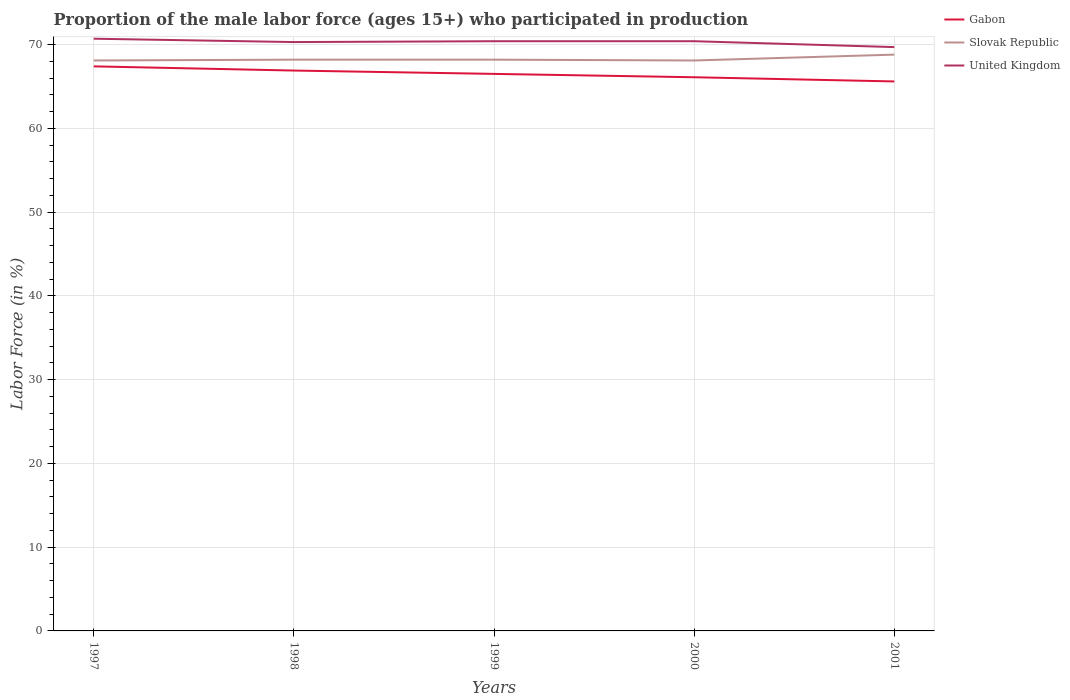Does the line corresponding to Gabon intersect with the line corresponding to Slovak Republic?
Your answer should be compact. No. Across all years, what is the maximum proportion of the male labor force who participated in production in United Kingdom?
Offer a very short reply. 69.7. What is the total proportion of the male labor force who participated in production in Gabon in the graph?
Offer a terse response. 1.3. What is the difference between the highest and the second highest proportion of the male labor force who participated in production in United Kingdom?
Provide a succinct answer. 1. Is the proportion of the male labor force who participated in production in Gabon strictly greater than the proportion of the male labor force who participated in production in Slovak Republic over the years?
Offer a very short reply. Yes. How many lines are there?
Your answer should be very brief. 3. Are the values on the major ticks of Y-axis written in scientific E-notation?
Give a very brief answer. No. Does the graph contain grids?
Make the answer very short. Yes. Where does the legend appear in the graph?
Give a very brief answer. Top right. How many legend labels are there?
Make the answer very short. 3. What is the title of the graph?
Provide a short and direct response. Proportion of the male labor force (ages 15+) who participated in production. What is the label or title of the X-axis?
Keep it short and to the point. Years. What is the label or title of the Y-axis?
Your answer should be very brief. Labor Force (in %). What is the Labor Force (in %) in Gabon in 1997?
Make the answer very short. 67.4. What is the Labor Force (in %) in Slovak Republic in 1997?
Provide a succinct answer. 68.1. What is the Labor Force (in %) of United Kingdom in 1997?
Make the answer very short. 70.7. What is the Labor Force (in %) in Gabon in 1998?
Offer a terse response. 66.9. What is the Labor Force (in %) in Slovak Republic in 1998?
Ensure brevity in your answer.  68.2. What is the Labor Force (in %) of United Kingdom in 1998?
Your answer should be very brief. 70.3. What is the Labor Force (in %) of Gabon in 1999?
Make the answer very short. 66.5. What is the Labor Force (in %) of Slovak Republic in 1999?
Provide a succinct answer. 68.2. What is the Labor Force (in %) of United Kingdom in 1999?
Your answer should be very brief. 70.4. What is the Labor Force (in %) in Gabon in 2000?
Offer a terse response. 66.1. What is the Labor Force (in %) of Slovak Republic in 2000?
Offer a very short reply. 68.1. What is the Labor Force (in %) of United Kingdom in 2000?
Your response must be concise. 70.4. What is the Labor Force (in %) in Gabon in 2001?
Your answer should be compact. 65.6. What is the Labor Force (in %) in Slovak Republic in 2001?
Offer a very short reply. 68.8. What is the Labor Force (in %) in United Kingdom in 2001?
Keep it short and to the point. 69.7. Across all years, what is the maximum Labor Force (in %) in Gabon?
Provide a succinct answer. 67.4. Across all years, what is the maximum Labor Force (in %) of Slovak Republic?
Make the answer very short. 68.8. Across all years, what is the maximum Labor Force (in %) in United Kingdom?
Your response must be concise. 70.7. Across all years, what is the minimum Labor Force (in %) in Gabon?
Your answer should be very brief. 65.6. Across all years, what is the minimum Labor Force (in %) of Slovak Republic?
Offer a very short reply. 68.1. Across all years, what is the minimum Labor Force (in %) of United Kingdom?
Provide a succinct answer. 69.7. What is the total Labor Force (in %) of Gabon in the graph?
Make the answer very short. 332.5. What is the total Labor Force (in %) of Slovak Republic in the graph?
Ensure brevity in your answer.  341.4. What is the total Labor Force (in %) in United Kingdom in the graph?
Make the answer very short. 351.5. What is the difference between the Labor Force (in %) in Gabon in 1997 and that in 1998?
Offer a terse response. 0.5. What is the difference between the Labor Force (in %) of United Kingdom in 1997 and that in 1998?
Make the answer very short. 0.4. What is the difference between the Labor Force (in %) of Gabon in 1997 and that in 1999?
Keep it short and to the point. 0.9. What is the difference between the Labor Force (in %) of United Kingdom in 1997 and that in 1999?
Your answer should be compact. 0.3. What is the difference between the Labor Force (in %) of Slovak Republic in 1997 and that in 2000?
Your answer should be compact. 0. What is the difference between the Labor Force (in %) of United Kingdom in 1997 and that in 2000?
Provide a succinct answer. 0.3. What is the difference between the Labor Force (in %) in Slovak Republic in 1997 and that in 2001?
Offer a terse response. -0.7. What is the difference between the Labor Force (in %) of Gabon in 1998 and that in 1999?
Offer a terse response. 0.4. What is the difference between the Labor Force (in %) of United Kingdom in 1998 and that in 1999?
Provide a short and direct response. -0.1. What is the difference between the Labor Force (in %) of Gabon in 1998 and that in 2000?
Your answer should be very brief. 0.8. What is the difference between the Labor Force (in %) of Slovak Republic in 1998 and that in 2000?
Give a very brief answer. 0.1. What is the difference between the Labor Force (in %) of United Kingdom in 1998 and that in 2000?
Keep it short and to the point. -0.1. What is the difference between the Labor Force (in %) of Slovak Republic in 1998 and that in 2001?
Provide a short and direct response. -0.6. What is the difference between the Labor Force (in %) in United Kingdom in 1999 and that in 2000?
Ensure brevity in your answer.  0. What is the difference between the Labor Force (in %) of Gabon in 1999 and that in 2001?
Provide a succinct answer. 0.9. What is the difference between the Labor Force (in %) in Gabon in 2000 and that in 2001?
Your answer should be compact. 0.5. What is the difference between the Labor Force (in %) of Slovak Republic in 2000 and that in 2001?
Make the answer very short. -0.7. What is the difference between the Labor Force (in %) of United Kingdom in 2000 and that in 2001?
Provide a short and direct response. 0.7. What is the difference between the Labor Force (in %) in Gabon in 1997 and the Labor Force (in %) in United Kingdom in 1998?
Your response must be concise. -2.9. What is the difference between the Labor Force (in %) of Gabon in 1997 and the Labor Force (in %) of Slovak Republic in 1999?
Give a very brief answer. -0.8. What is the difference between the Labor Force (in %) of Gabon in 1997 and the Labor Force (in %) of United Kingdom in 1999?
Offer a terse response. -3. What is the difference between the Labor Force (in %) of Slovak Republic in 1997 and the Labor Force (in %) of United Kingdom in 1999?
Give a very brief answer. -2.3. What is the difference between the Labor Force (in %) in Slovak Republic in 1997 and the Labor Force (in %) in United Kingdom in 2000?
Ensure brevity in your answer.  -2.3. What is the difference between the Labor Force (in %) in Gabon in 1997 and the Labor Force (in %) in Slovak Republic in 2001?
Keep it short and to the point. -1.4. What is the difference between the Labor Force (in %) of Slovak Republic in 1997 and the Labor Force (in %) of United Kingdom in 2001?
Your answer should be very brief. -1.6. What is the difference between the Labor Force (in %) of Gabon in 1998 and the Labor Force (in %) of United Kingdom in 1999?
Your response must be concise. -3.5. What is the difference between the Labor Force (in %) of Slovak Republic in 1998 and the Labor Force (in %) of United Kingdom in 1999?
Ensure brevity in your answer.  -2.2. What is the difference between the Labor Force (in %) in Gabon in 1998 and the Labor Force (in %) in Slovak Republic in 2000?
Keep it short and to the point. -1.2. What is the difference between the Labor Force (in %) in Gabon in 1998 and the Labor Force (in %) in United Kingdom in 2000?
Ensure brevity in your answer.  -3.5. What is the difference between the Labor Force (in %) of Slovak Republic in 1998 and the Labor Force (in %) of United Kingdom in 2000?
Offer a very short reply. -2.2. What is the difference between the Labor Force (in %) of Gabon in 1998 and the Labor Force (in %) of Slovak Republic in 2001?
Offer a very short reply. -1.9. What is the difference between the Labor Force (in %) of Gabon in 1999 and the Labor Force (in %) of Slovak Republic in 2001?
Provide a short and direct response. -2.3. What is the difference between the Labor Force (in %) of Gabon in 1999 and the Labor Force (in %) of United Kingdom in 2001?
Make the answer very short. -3.2. What is the difference between the Labor Force (in %) of Slovak Republic in 1999 and the Labor Force (in %) of United Kingdom in 2001?
Your response must be concise. -1.5. What is the difference between the Labor Force (in %) in Gabon in 2000 and the Labor Force (in %) in Slovak Republic in 2001?
Offer a very short reply. -2.7. What is the average Labor Force (in %) in Gabon per year?
Keep it short and to the point. 66.5. What is the average Labor Force (in %) in Slovak Republic per year?
Give a very brief answer. 68.28. What is the average Labor Force (in %) in United Kingdom per year?
Offer a very short reply. 70.3. In the year 1997, what is the difference between the Labor Force (in %) in Gabon and Labor Force (in %) in United Kingdom?
Your answer should be very brief. -3.3. In the year 1997, what is the difference between the Labor Force (in %) in Slovak Republic and Labor Force (in %) in United Kingdom?
Provide a succinct answer. -2.6. In the year 1998, what is the difference between the Labor Force (in %) in Gabon and Labor Force (in %) in Slovak Republic?
Offer a very short reply. -1.3. In the year 1998, what is the difference between the Labor Force (in %) in Slovak Republic and Labor Force (in %) in United Kingdom?
Offer a terse response. -2.1. In the year 1999, what is the difference between the Labor Force (in %) of Gabon and Labor Force (in %) of Slovak Republic?
Provide a short and direct response. -1.7. In the year 2000, what is the difference between the Labor Force (in %) in Gabon and Labor Force (in %) in Slovak Republic?
Your response must be concise. -2. In the year 2000, what is the difference between the Labor Force (in %) of Slovak Republic and Labor Force (in %) of United Kingdom?
Your answer should be compact. -2.3. In the year 2001, what is the difference between the Labor Force (in %) in Gabon and Labor Force (in %) in United Kingdom?
Your response must be concise. -4.1. In the year 2001, what is the difference between the Labor Force (in %) of Slovak Republic and Labor Force (in %) of United Kingdom?
Ensure brevity in your answer.  -0.9. What is the ratio of the Labor Force (in %) of Gabon in 1997 to that in 1998?
Provide a short and direct response. 1.01. What is the ratio of the Labor Force (in %) in Slovak Republic in 1997 to that in 1998?
Make the answer very short. 1. What is the ratio of the Labor Force (in %) in Gabon in 1997 to that in 1999?
Make the answer very short. 1.01. What is the ratio of the Labor Force (in %) in United Kingdom in 1997 to that in 1999?
Your answer should be very brief. 1. What is the ratio of the Labor Force (in %) in Gabon in 1997 to that in 2000?
Offer a very short reply. 1.02. What is the ratio of the Labor Force (in %) in Gabon in 1997 to that in 2001?
Offer a terse response. 1.03. What is the ratio of the Labor Force (in %) in Slovak Republic in 1997 to that in 2001?
Ensure brevity in your answer.  0.99. What is the ratio of the Labor Force (in %) of United Kingdom in 1997 to that in 2001?
Offer a terse response. 1.01. What is the ratio of the Labor Force (in %) of Gabon in 1998 to that in 1999?
Your answer should be compact. 1.01. What is the ratio of the Labor Force (in %) in Slovak Republic in 1998 to that in 1999?
Provide a succinct answer. 1. What is the ratio of the Labor Force (in %) of Gabon in 1998 to that in 2000?
Give a very brief answer. 1.01. What is the ratio of the Labor Force (in %) of Slovak Republic in 1998 to that in 2000?
Your response must be concise. 1. What is the ratio of the Labor Force (in %) in United Kingdom in 1998 to that in 2000?
Your answer should be very brief. 1. What is the ratio of the Labor Force (in %) in Gabon in 1998 to that in 2001?
Offer a terse response. 1.02. What is the ratio of the Labor Force (in %) of United Kingdom in 1998 to that in 2001?
Your answer should be compact. 1.01. What is the ratio of the Labor Force (in %) of Gabon in 1999 to that in 2000?
Provide a short and direct response. 1.01. What is the ratio of the Labor Force (in %) of Gabon in 1999 to that in 2001?
Your answer should be compact. 1.01. What is the ratio of the Labor Force (in %) in Slovak Republic in 1999 to that in 2001?
Make the answer very short. 0.99. What is the ratio of the Labor Force (in %) in Gabon in 2000 to that in 2001?
Ensure brevity in your answer.  1.01. What is the difference between the highest and the second highest Labor Force (in %) of Slovak Republic?
Offer a very short reply. 0.6. What is the difference between the highest and the second highest Labor Force (in %) in United Kingdom?
Give a very brief answer. 0.3. What is the difference between the highest and the lowest Labor Force (in %) in Gabon?
Ensure brevity in your answer.  1.8. 